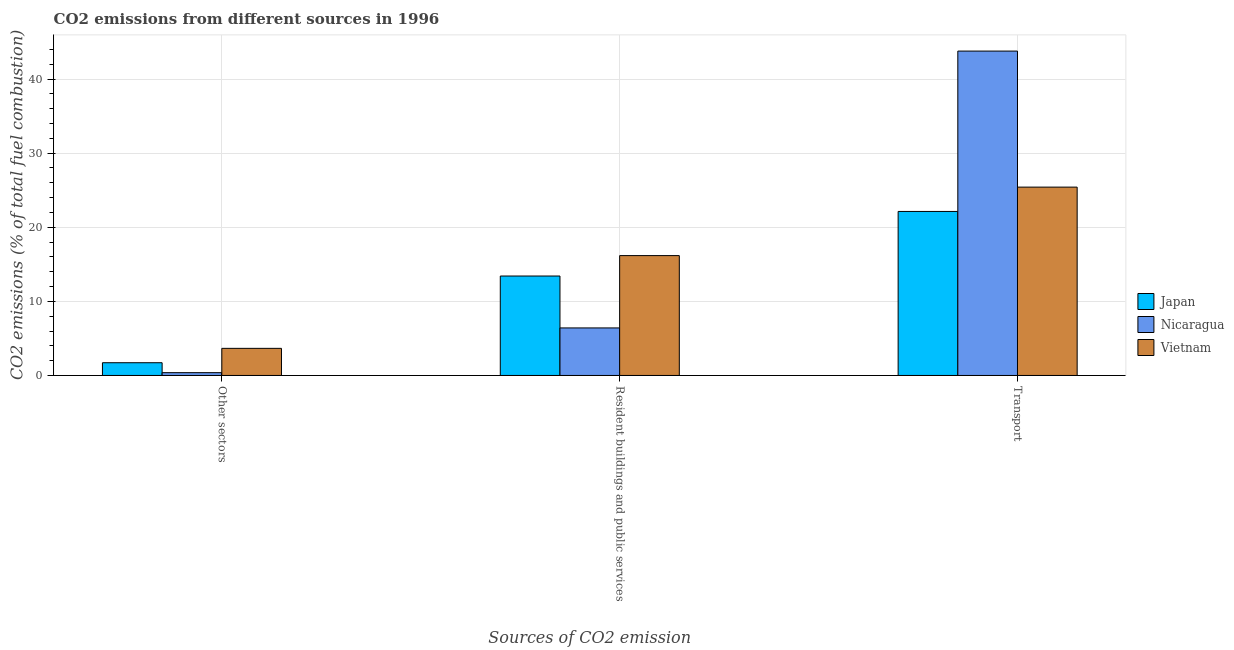Are the number of bars per tick equal to the number of legend labels?
Provide a short and direct response. Yes. What is the label of the 2nd group of bars from the left?
Offer a very short reply. Resident buildings and public services. What is the percentage of co2 emissions from transport in Vietnam?
Provide a succinct answer. 25.42. Across all countries, what is the maximum percentage of co2 emissions from other sectors?
Ensure brevity in your answer.  3.66. Across all countries, what is the minimum percentage of co2 emissions from other sectors?
Provide a short and direct response. 0.38. In which country was the percentage of co2 emissions from transport maximum?
Make the answer very short. Nicaragua. What is the total percentage of co2 emissions from transport in the graph?
Keep it short and to the point. 91.32. What is the difference between the percentage of co2 emissions from other sectors in Vietnam and that in Nicaragua?
Keep it short and to the point. 3.28. What is the difference between the percentage of co2 emissions from other sectors in Japan and the percentage of co2 emissions from resident buildings and public services in Vietnam?
Provide a succinct answer. -14.46. What is the average percentage of co2 emissions from other sectors per country?
Provide a succinct answer. 1.92. What is the difference between the percentage of co2 emissions from other sectors and percentage of co2 emissions from resident buildings and public services in Nicaragua?
Offer a very short reply. -6.04. What is the ratio of the percentage of co2 emissions from resident buildings and public services in Vietnam to that in Japan?
Ensure brevity in your answer.  1.21. Is the percentage of co2 emissions from transport in Japan less than that in Vietnam?
Keep it short and to the point. Yes. Is the difference between the percentage of co2 emissions from transport in Japan and Vietnam greater than the difference between the percentage of co2 emissions from other sectors in Japan and Vietnam?
Ensure brevity in your answer.  No. What is the difference between the highest and the second highest percentage of co2 emissions from resident buildings and public services?
Give a very brief answer. 2.75. What is the difference between the highest and the lowest percentage of co2 emissions from other sectors?
Your answer should be very brief. 3.28. Is the sum of the percentage of co2 emissions from transport in Vietnam and Nicaragua greater than the maximum percentage of co2 emissions from resident buildings and public services across all countries?
Keep it short and to the point. Yes. What does the 2nd bar from the left in Transport represents?
Offer a very short reply. Nicaragua. What does the 2nd bar from the right in Resident buildings and public services represents?
Offer a terse response. Nicaragua. Is it the case that in every country, the sum of the percentage of co2 emissions from other sectors and percentage of co2 emissions from resident buildings and public services is greater than the percentage of co2 emissions from transport?
Provide a succinct answer. No. How many bars are there?
Give a very brief answer. 9. Are all the bars in the graph horizontal?
Offer a terse response. No. How are the legend labels stacked?
Provide a short and direct response. Vertical. What is the title of the graph?
Provide a short and direct response. CO2 emissions from different sources in 1996. What is the label or title of the X-axis?
Give a very brief answer. Sources of CO2 emission. What is the label or title of the Y-axis?
Your answer should be very brief. CO2 emissions (% of total fuel combustion). What is the CO2 emissions (% of total fuel combustion) of Japan in Other sectors?
Ensure brevity in your answer.  1.72. What is the CO2 emissions (% of total fuel combustion) of Nicaragua in Other sectors?
Keep it short and to the point. 0.38. What is the CO2 emissions (% of total fuel combustion) in Vietnam in Other sectors?
Ensure brevity in your answer.  3.66. What is the CO2 emissions (% of total fuel combustion) in Japan in Resident buildings and public services?
Offer a terse response. 13.42. What is the CO2 emissions (% of total fuel combustion) of Nicaragua in Resident buildings and public services?
Give a very brief answer. 6.42. What is the CO2 emissions (% of total fuel combustion) of Vietnam in Resident buildings and public services?
Offer a very short reply. 16.17. What is the CO2 emissions (% of total fuel combustion) in Japan in Transport?
Give a very brief answer. 22.13. What is the CO2 emissions (% of total fuel combustion) in Nicaragua in Transport?
Make the answer very short. 43.77. What is the CO2 emissions (% of total fuel combustion) in Vietnam in Transport?
Make the answer very short. 25.42. Across all Sources of CO2 emission, what is the maximum CO2 emissions (% of total fuel combustion) in Japan?
Ensure brevity in your answer.  22.13. Across all Sources of CO2 emission, what is the maximum CO2 emissions (% of total fuel combustion) in Nicaragua?
Your answer should be compact. 43.77. Across all Sources of CO2 emission, what is the maximum CO2 emissions (% of total fuel combustion) of Vietnam?
Provide a succinct answer. 25.42. Across all Sources of CO2 emission, what is the minimum CO2 emissions (% of total fuel combustion) of Japan?
Your answer should be compact. 1.72. Across all Sources of CO2 emission, what is the minimum CO2 emissions (% of total fuel combustion) of Nicaragua?
Your answer should be very brief. 0.38. Across all Sources of CO2 emission, what is the minimum CO2 emissions (% of total fuel combustion) in Vietnam?
Provide a short and direct response. 3.66. What is the total CO2 emissions (% of total fuel combustion) of Japan in the graph?
Keep it short and to the point. 37.27. What is the total CO2 emissions (% of total fuel combustion) of Nicaragua in the graph?
Offer a very short reply. 50.57. What is the total CO2 emissions (% of total fuel combustion) in Vietnam in the graph?
Provide a short and direct response. 45.25. What is the difference between the CO2 emissions (% of total fuel combustion) of Japan in Other sectors and that in Resident buildings and public services?
Give a very brief answer. -11.7. What is the difference between the CO2 emissions (% of total fuel combustion) of Nicaragua in Other sectors and that in Resident buildings and public services?
Your answer should be very brief. -6.04. What is the difference between the CO2 emissions (% of total fuel combustion) of Vietnam in Other sectors and that in Resident buildings and public services?
Your answer should be compact. -12.52. What is the difference between the CO2 emissions (% of total fuel combustion) of Japan in Other sectors and that in Transport?
Keep it short and to the point. -20.41. What is the difference between the CO2 emissions (% of total fuel combustion) of Nicaragua in Other sectors and that in Transport?
Offer a very short reply. -43.4. What is the difference between the CO2 emissions (% of total fuel combustion) of Vietnam in Other sectors and that in Transport?
Your answer should be very brief. -21.76. What is the difference between the CO2 emissions (% of total fuel combustion) of Japan in Resident buildings and public services and that in Transport?
Offer a terse response. -8.71. What is the difference between the CO2 emissions (% of total fuel combustion) of Nicaragua in Resident buildings and public services and that in Transport?
Your response must be concise. -37.36. What is the difference between the CO2 emissions (% of total fuel combustion) in Vietnam in Resident buildings and public services and that in Transport?
Ensure brevity in your answer.  -9.24. What is the difference between the CO2 emissions (% of total fuel combustion) in Japan in Other sectors and the CO2 emissions (% of total fuel combustion) in Nicaragua in Resident buildings and public services?
Make the answer very short. -4.7. What is the difference between the CO2 emissions (% of total fuel combustion) of Japan in Other sectors and the CO2 emissions (% of total fuel combustion) of Vietnam in Resident buildings and public services?
Provide a short and direct response. -14.46. What is the difference between the CO2 emissions (% of total fuel combustion) in Nicaragua in Other sectors and the CO2 emissions (% of total fuel combustion) in Vietnam in Resident buildings and public services?
Ensure brevity in your answer.  -15.8. What is the difference between the CO2 emissions (% of total fuel combustion) in Japan in Other sectors and the CO2 emissions (% of total fuel combustion) in Nicaragua in Transport?
Offer a terse response. -42.06. What is the difference between the CO2 emissions (% of total fuel combustion) in Japan in Other sectors and the CO2 emissions (% of total fuel combustion) in Vietnam in Transport?
Your response must be concise. -23.7. What is the difference between the CO2 emissions (% of total fuel combustion) of Nicaragua in Other sectors and the CO2 emissions (% of total fuel combustion) of Vietnam in Transport?
Provide a succinct answer. -25.04. What is the difference between the CO2 emissions (% of total fuel combustion) in Japan in Resident buildings and public services and the CO2 emissions (% of total fuel combustion) in Nicaragua in Transport?
Provide a short and direct response. -30.35. What is the difference between the CO2 emissions (% of total fuel combustion) in Japan in Resident buildings and public services and the CO2 emissions (% of total fuel combustion) in Vietnam in Transport?
Offer a terse response. -12. What is the difference between the CO2 emissions (% of total fuel combustion) of Nicaragua in Resident buildings and public services and the CO2 emissions (% of total fuel combustion) of Vietnam in Transport?
Offer a very short reply. -19. What is the average CO2 emissions (% of total fuel combustion) in Japan per Sources of CO2 emission?
Provide a short and direct response. 12.42. What is the average CO2 emissions (% of total fuel combustion) in Nicaragua per Sources of CO2 emission?
Give a very brief answer. 16.86. What is the average CO2 emissions (% of total fuel combustion) of Vietnam per Sources of CO2 emission?
Ensure brevity in your answer.  15.08. What is the difference between the CO2 emissions (% of total fuel combustion) in Japan and CO2 emissions (% of total fuel combustion) in Nicaragua in Other sectors?
Offer a terse response. 1.34. What is the difference between the CO2 emissions (% of total fuel combustion) of Japan and CO2 emissions (% of total fuel combustion) of Vietnam in Other sectors?
Keep it short and to the point. -1.94. What is the difference between the CO2 emissions (% of total fuel combustion) of Nicaragua and CO2 emissions (% of total fuel combustion) of Vietnam in Other sectors?
Provide a short and direct response. -3.28. What is the difference between the CO2 emissions (% of total fuel combustion) of Japan and CO2 emissions (% of total fuel combustion) of Nicaragua in Resident buildings and public services?
Provide a short and direct response. 7. What is the difference between the CO2 emissions (% of total fuel combustion) in Japan and CO2 emissions (% of total fuel combustion) in Vietnam in Resident buildings and public services?
Your response must be concise. -2.75. What is the difference between the CO2 emissions (% of total fuel combustion) in Nicaragua and CO2 emissions (% of total fuel combustion) in Vietnam in Resident buildings and public services?
Give a very brief answer. -9.76. What is the difference between the CO2 emissions (% of total fuel combustion) in Japan and CO2 emissions (% of total fuel combustion) in Nicaragua in Transport?
Keep it short and to the point. -21.64. What is the difference between the CO2 emissions (% of total fuel combustion) of Japan and CO2 emissions (% of total fuel combustion) of Vietnam in Transport?
Ensure brevity in your answer.  -3.28. What is the difference between the CO2 emissions (% of total fuel combustion) of Nicaragua and CO2 emissions (% of total fuel combustion) of Vietnam in Transport?
Your answer should be very brief. 18.36. What is the ratio of the CO2 emissions (% of total fuel combustion) in Japan in Other sectors to that in Resident buildings and public services?
Offer a terse response. 0.13. What is the ratio of the CO2 emissions (% of total fuel combustion) of Nicaragua in Other sectors to that in Resident buildings and public services?
Your answer should be very brief. 0.06. What is the ratio of the CO2 emissions (% of total fuel combustion) of Vietnam in Other sectors to that in Resident buildings and public services?
Your answer should be compact. 0.23. What is the ratio of the CO2 emissions (% of total fuel combustion) of Japan in Other sectors to that in Transport?
Keep it short and to the point. 0.08. What is the ratio of the CO2 emissions (% of total fuel combustion) of Nicaragua in Other sectors to that in Transport?
Your answer should be very brief. 0.01. What is the ratio of the CO2 emissions (% of total fuel combustion) in Vietnam in Other sectors to that in Transport?
Offer a very short reply. 0.14. What is the ratio of the CO2 emissions (% of total fuel combustion) of Japan in Resident buildings and public services to that in Transport?
Offer a very short reply. 0.61. What is the ratio of the CO2 emissions (% of total fuel combustion) of Nicaragua in Resident buildings and public services to that in Transport?
Offer a very short reply. 0.15. What is the ratio of the CO2 emissions (% of total fuel combustion) of Vietnam in Resident buildings and public services to that in Transport?
Provide a short and direct response. 0.64. What is the difference between the highest and the second highest CO2 emissions (% of total fuel combustion) in Japan?
Your response must be concise. 8.71. What is the difference between the highest and the second highest CO2 emissions (% of total fuel combustion) of Nicaragua?
Offer a very short reply. 37.36. What is the difference between the highest and the second highest CO2 emissions (% of total fuel combustion) in Vietnam?
Make the answer very short. 9.24. What is the difference between the highest and the lowest CO2 emissions (% of total fuel combustion) in Japan?
Offer a very short reply. 20.41. What is the difference between the highest and the lowest CO2 emissions (% of total fuel combustion) in Nicaragua?
Keep it short and to the point. 43.4. What is the difference between the highest and the lowest CO2 emissions (% of total fuel combustion) in Vietnam?
Provide a succinct answer. 21.76. 